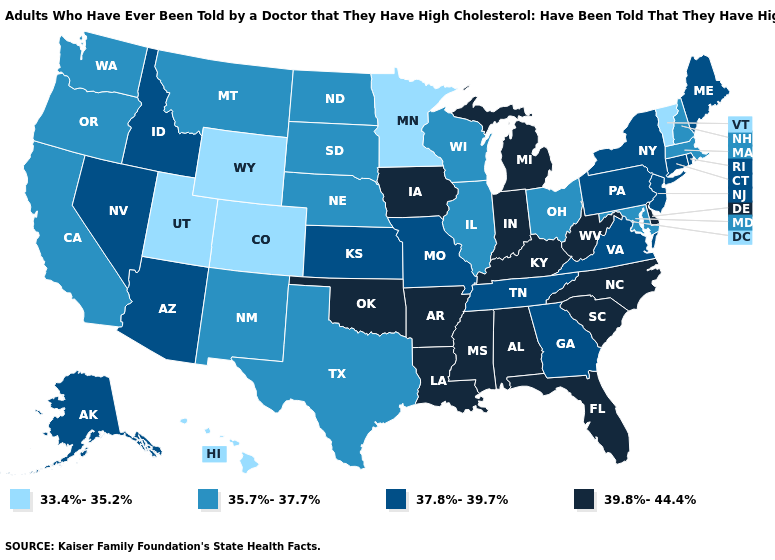What is the highest value in states that border Ohio?
Write a very short answer. 39.8%-44.4%. What is the value of Maryland?
Concise answer only. 35.7%-37.7%. Name the states that have a value in the range 35.7%-37.7%?
Quick response, please. California, Illinois, Maryland, Massachusetts, Montana, Nebraska, New Hampshire, New Mexico, North Dakota, Ohio, Oregon, South Dakota, Texas, Washington, Wisconsin. Among the states that border North Dakota , does Minnesota have the lowest value?
Answer briefly. Yes. What is the highest value in states that border Colorado?
Give a very brief answer. 39.8%-44.4%. Does Nebraska have the highest value in the USA?
Short answer required. No. Does North Carolina have the highest value in the USA?
Answer briefly. Yes. Name the states that have a value in the range 37.8%-39.7%?
Give a very brief answer. Alaska, Arizona, Connecticut, Georgia, Idaho, Kansas, Maine, Missouri, Nevada, New Jersey, New York, Pennsylvania, Rhode Island, Tennessee, Virginia. What is the value of Oregon?
Give a very brief answer. 35.7%-37.7%. What is the value of Massachusetts?
Quick response, please. 35.7%-37.7%. Which states hav the highest value in the MidWest?
Give a very brief answer. Indiana, Iowa, Michigan. Among the states that border Iowa , which have the lowest value?
Keep it brief. Minnesota. Among the states that border Virginia , does Tennessee have the lowest value?
Answer briefly. No. What is the lowest value in the USA?
Be succinct. 33.4%-35.2%. Does Delaware have the highest value in the USA?
Short answer required. Yes. 